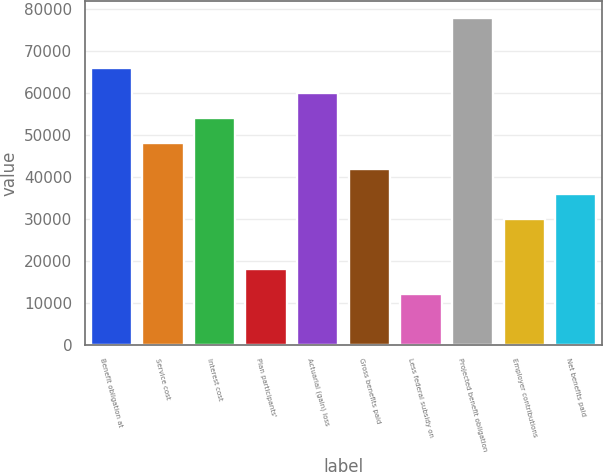Convert chart. <chart><loc_0><loc_0><loc_500><loc_500><bar_chart><fcel>Benefit obligation at<fcel>Service cost<fcel>Interest cost<fcel>Plan participants'<fcel>Actuarial (gain) loss<fcel>Gross benefits paid<fcel>Less federal subsidy on<fcel>Projected benefit obligation<fcel>Employer contributions<fcel>Net benefits paid<nl><fcel>65943.3<fcel>47960.2<fcel>53954.6<fcel>17988.5<fcel>59949<fcel>41965.9<fcel>11994.1<fcel>77932.1<fcel>29977.2<fcel>35971.5<nl></chart> 